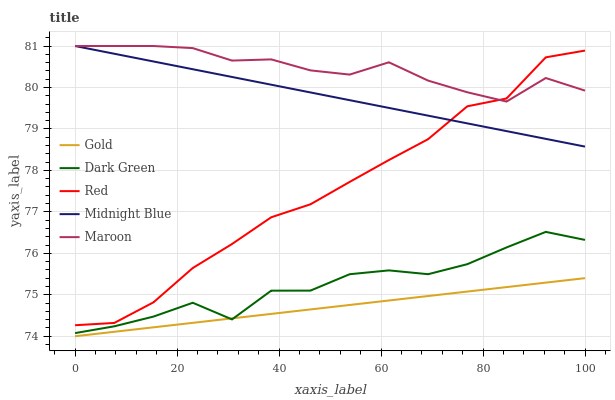Does Gold have the minimum area under the curve?
Answer yes or no. Yes. Does Maroon have the maximum area under the curve?
Answer yes or no. Yes. Does Midnight Blue have the minimum area under the curve?
Answer yes or no. No. Does Midnight Blue have the maximum area under the curve?
Answer yes or no. No. Is Gold the smoothest?
Answer yes or no. Yes. Is Dark Green the roughest?
Answer yes or no. Yes. Is Midnight Blue the smoothest?
Answer yes or no. No. Is Midnight Blue the roughest?
Answer yes or no. No. Does Gold have the lowest value?
Answer yes or no. Yes. Does Midnight Blue have the lowest value?
Answer yes or no. No. Does Midnight Blue have the highest value?
Answer yes or no. Yes. Does Red have the highest value?
Answer yes or no. No. Is Dark Green less than Maroon?
Answer yes or no. Yes. Is Red greater than Gold?
Answer yes or no. Yes. Does Midnight Blue intersect Maroon?
Answer yes or no. Yes. Is Midnight Blue less than Maroon?
Answer yes or no. No. Is Midnight Blue greater than Maroon?
Answer yes or no. No. Does Dark Green intersect Maroon?
Answer yes or no. No. 